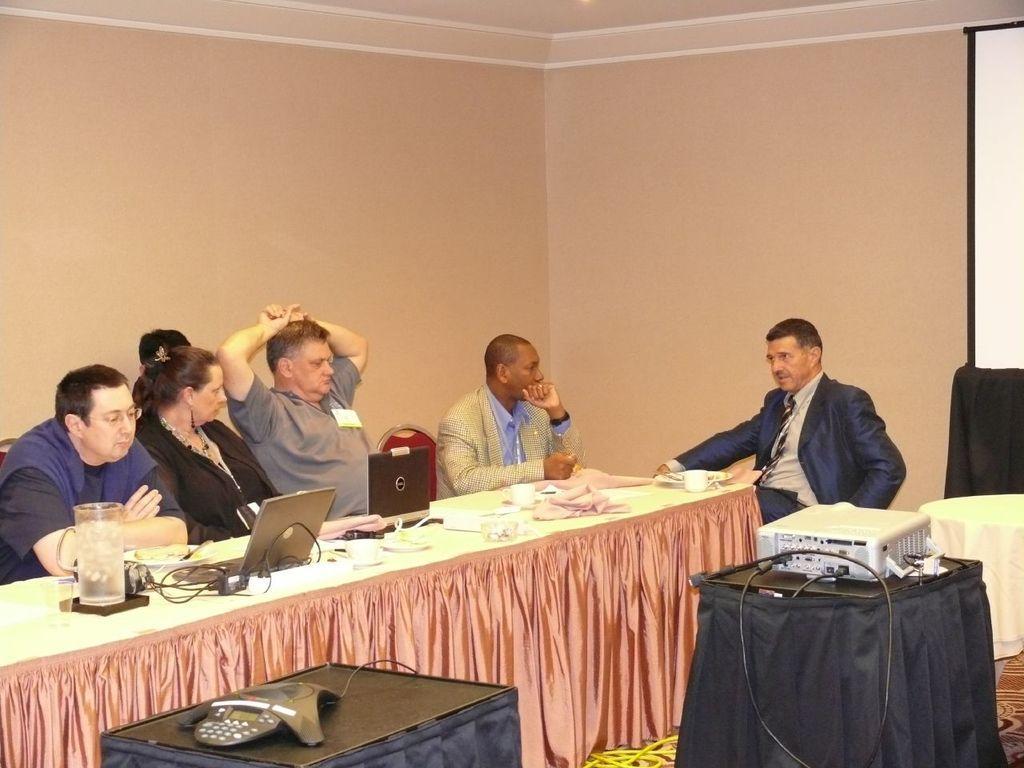Can you describe this image briefly? In this image, group of people are sat. In-front of them, there is a white color table and curtain here. Few items are placed on a table. On bottom and right side of the image, we can see black color table. Here there is an item placed. On right side, we can see projector and screen. at the bottom, we can see some wires. Top of the image, there is a cream color wall. 